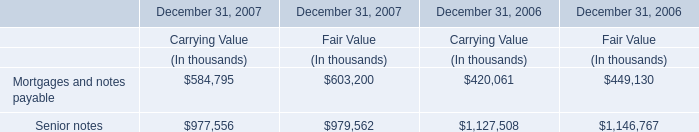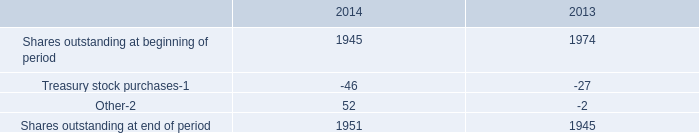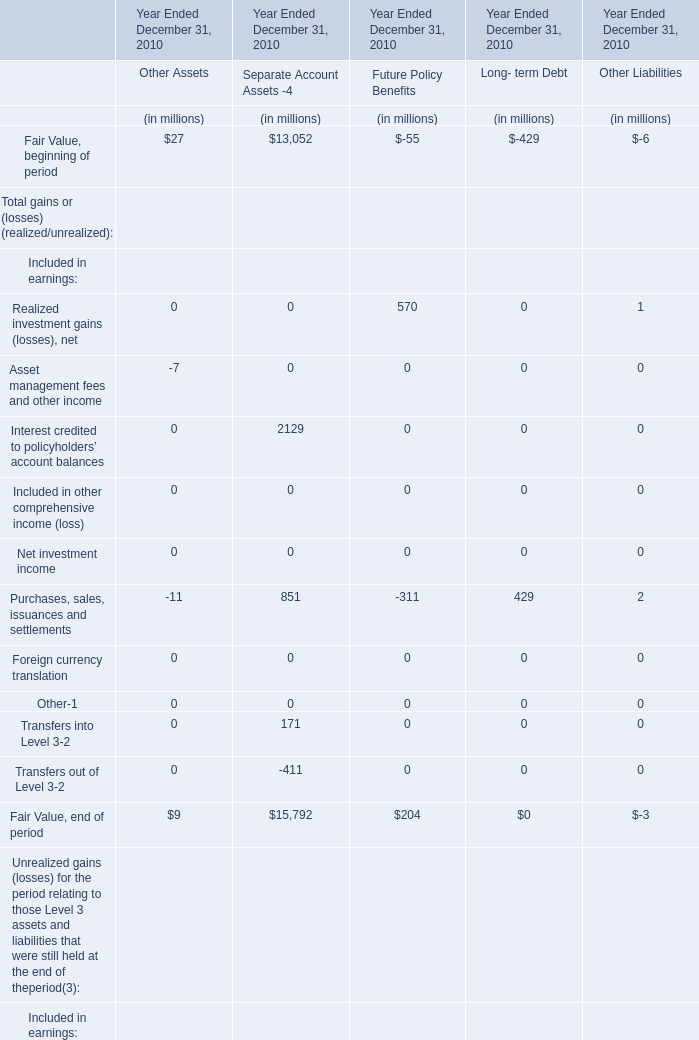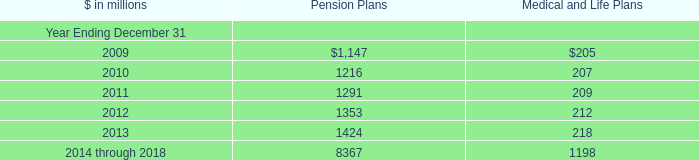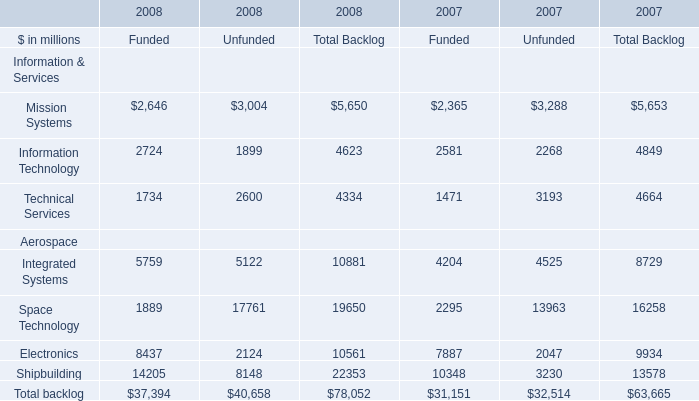What is the highest Fair Value, end of period for Year Ended December 31, 2010 as As the chart 2 shows? (in million) 
Answer: 15792. 